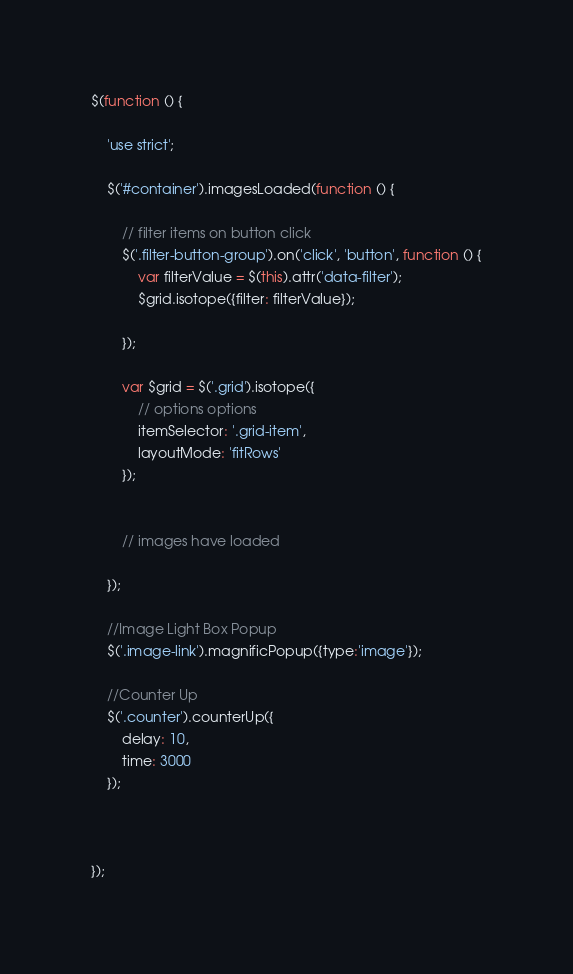Convert code to text. <code><loc_0><loc_0><loc_500><loc_500><_JavaScript_>$(function () {

    'use strict';

    $('#container').imagesLoaded(function () {

        // filter items on button click
        $('.filter-button-group').on('click', 'button', function () {
            var filterValue = $(this).attr('data-filter');
            $grid.isotope({filter: filterValue});
            
        });

        var $grid = $('.grid').isotope({
            // options options
            itemSelector: '.grid-item',
            layoutMode: 'fitRows'
        });
        

        // images have loaded

    });

    //Image Light Box Popup
    $('.image-link').magnificPopup({type:'image'});

    //Counter Up
    $('.counter').counterUp({
        delay: 10,
        time: 3000
    });
    
    

});

</code> 